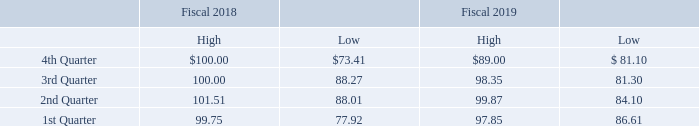ITEM 5. MARKET FOR REGISTRANT’S COMMON EQUITY, RELATED STOCKHOLDER MATTERS AND ISSUER PURCHASES OF EQUITY SECURITIES ITEM 5. MARKET FOR REGISTRANT’S COMMON EQUITY, RELATED STOCKHOLDER MATTERS AND ISSUER PURCHASES OF EQUITY SECURITIES
MARKET FOR COMMON STOCK
The Company’s common stock trades on NYSE American under the trading symbol “DIT”. As of October 31, 2019 the closing price of our common stock on NYSE American was $73.00 and there were 565,942 common shares outstanding. As of that date, the Company had approximately 521 persons holding common shares beneficially of which approximately 121 are shareholders of record (including direct participants in the Depository Trust Company). The following table reflects the range of the high and low closing prices per share of the Company’s common stock reported by NYSE American for fiscal 2019 and 2018.
What is the closing price of the company's common stock on NYSE American as of October 31, 2019? $73.00. What are the respective high and low closing prices per share of the Company’s common stock reported by NYSE American for the 1st Quarter of fiscal 2019? 99.75, 77.92. What are the respective high and low closing prices per share of the Company’s common stock reported by NYSE American for the 2nd Quarter of fiscal 2019? 101.51, 88.01. What is the average high closing prices per share of the Company’s common stock reported by NYSE American for fiscal 2019? (100.00 + 100.00 + 101.51 + 99.75)/4 
Answer: 100.31. What is the average high closing prices per share of the Company’s common stock reported by NYSE American for fiscal 2018? (89.00 + 98.35 + 99.87 + 97.85)/4 
Answer: 96.27. What is the percentage change in the high closing prices per share of the Company’s common stock reported by NYSE American between Quarter 4 of fiscal 2018 and 2019?
Answer scale should be: percent. (100-89)/89 
Answer: 12.36. 